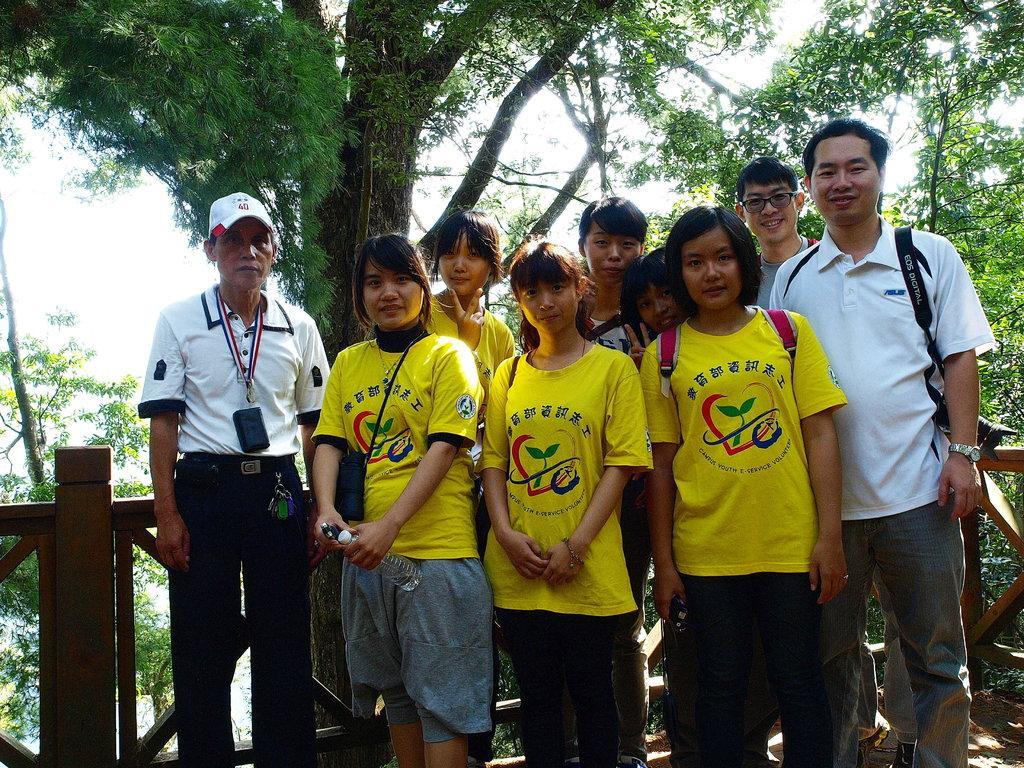Describe this image in one or two sentences. There are persons in different color dresses, some of them are smiling, standing near wooden fencing. In the background, there are trees and there is sky. 